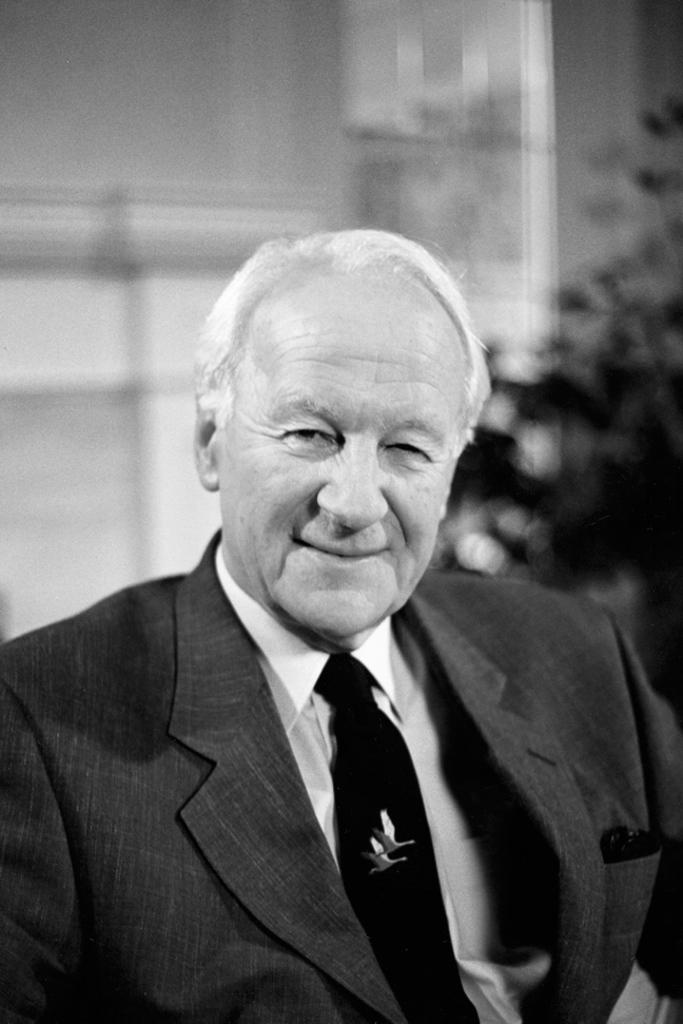What is the main subject in the foreground of the image? There is a man in the foreground of the image. What is the man wearing? The man is wearing a suit and a tie. What is the color scheme of the image? The image is in black and white. How would you describe the background of the image? The background of the image is blurry. Are there any sweaters visible in the image? There are no sweaters present in the image. How many spiders can be seen crawling on the man's suit in the image? There are no spiders present in the image. 